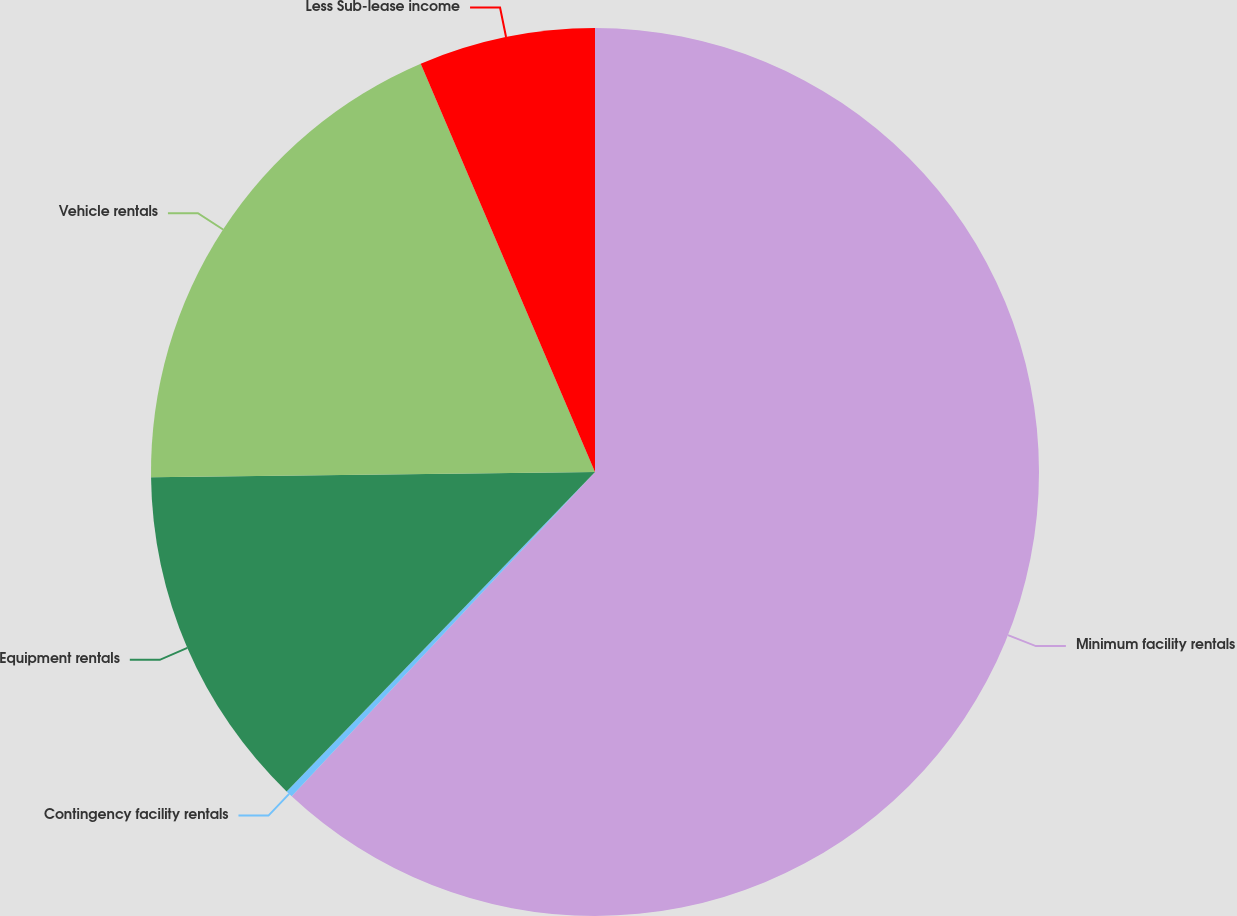Convert chart to OTSL. <chart><loc_0><loc_0><loc_500><loc_500><pie_chart><fcel>Minimum facility rentals<fcel>Contingency facility rentals<fcel>Equipment rentals<fcel>Vehicle rentals<fcel>Less Sub-lease income<nl><fcel>61.97%<fcel>0.25%<fcel>12.59%<fcel>18.77%<fcel>6.42%<nl></chart> 